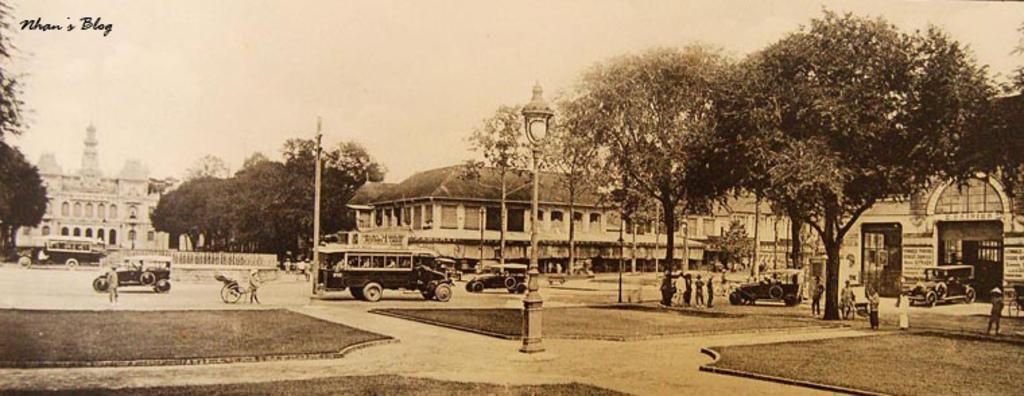What structures are present in the image? There are poles, trees, buildings, and vehicles in the image. What is the location of the people in the image? The people are on the ground in the image. Can you describe the natural elements in the image? There are trees in the image. What type of man-made structures can be seen in the image? There are buildings in the image. What type of skirt is being worn by the trees in the image? There are no skirts present in the image, as the trees are natural elements and do not wear clothing. What process is being carried out by the vehicles in the image? The provided facts do not mention any specific process being carried out by the vehicles; they are simply present in the image. 